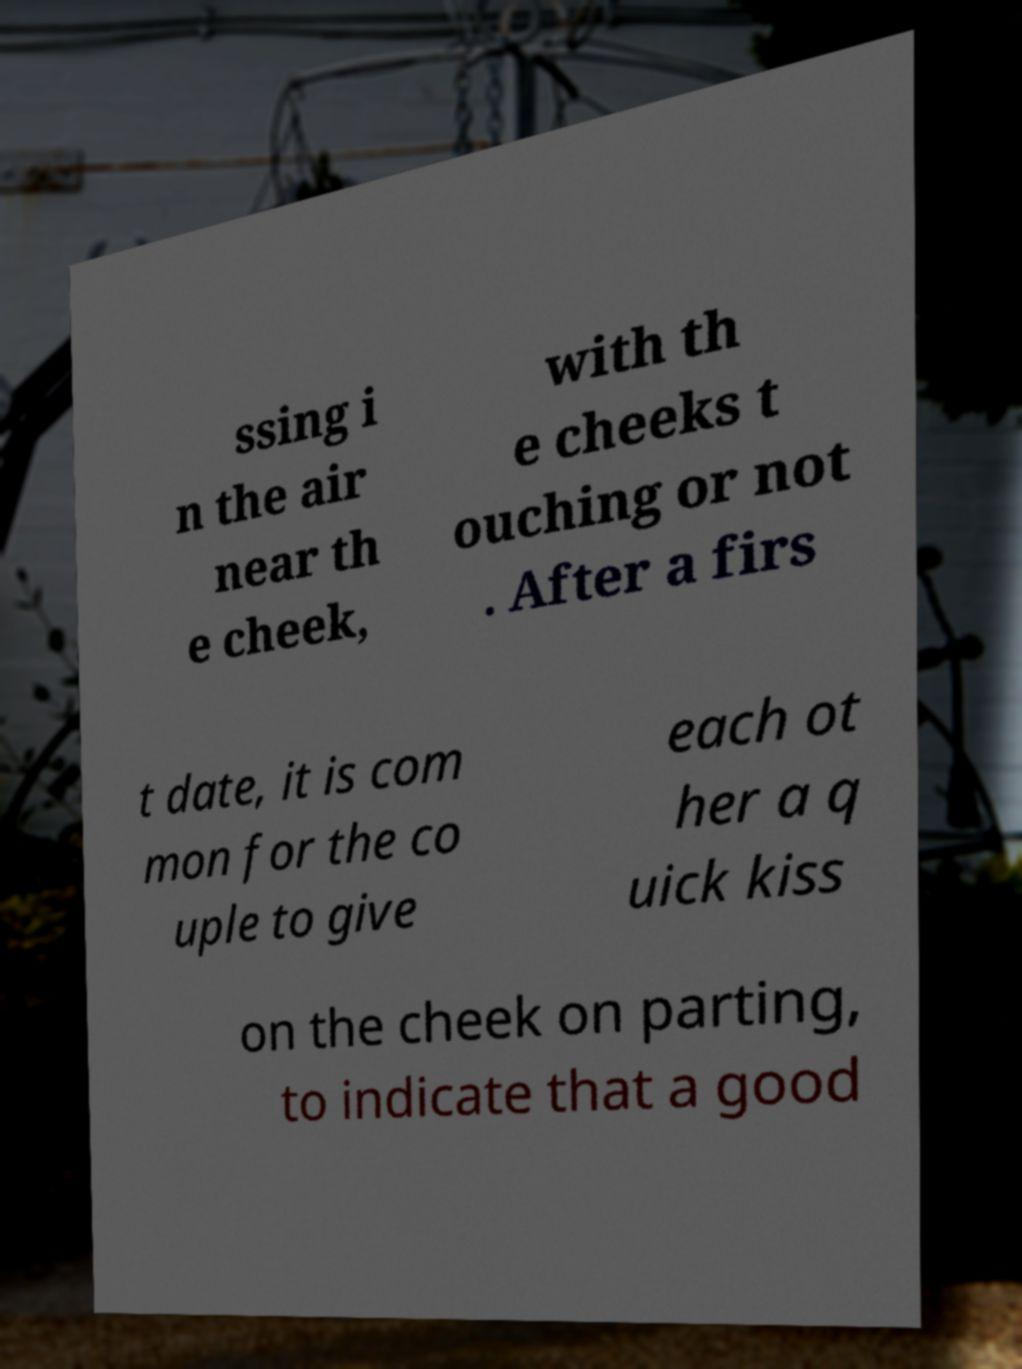Could you assist in decoding the text presented in this image and type it out clearly? ssing i n the air near th e cheek, with th e cheeks t ouching or not . After a firs t date, it is com mon for the co uple to give each ot her a q uick kiss on the cheek on parting, to indicate that a good 